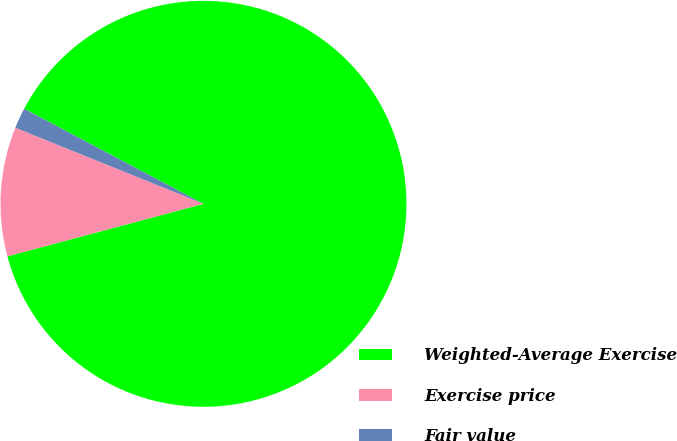Convert chart to OTSL. <chart><loc_0><loc_0><loc_500><loc_500><pie_chart><fcel>Weighted-Average Exercise<fcel>Exercise price<fcel>Fair value<nl><fcel>88.08%<fcel>10.28%<fcel>1.64%<nl></chart> 